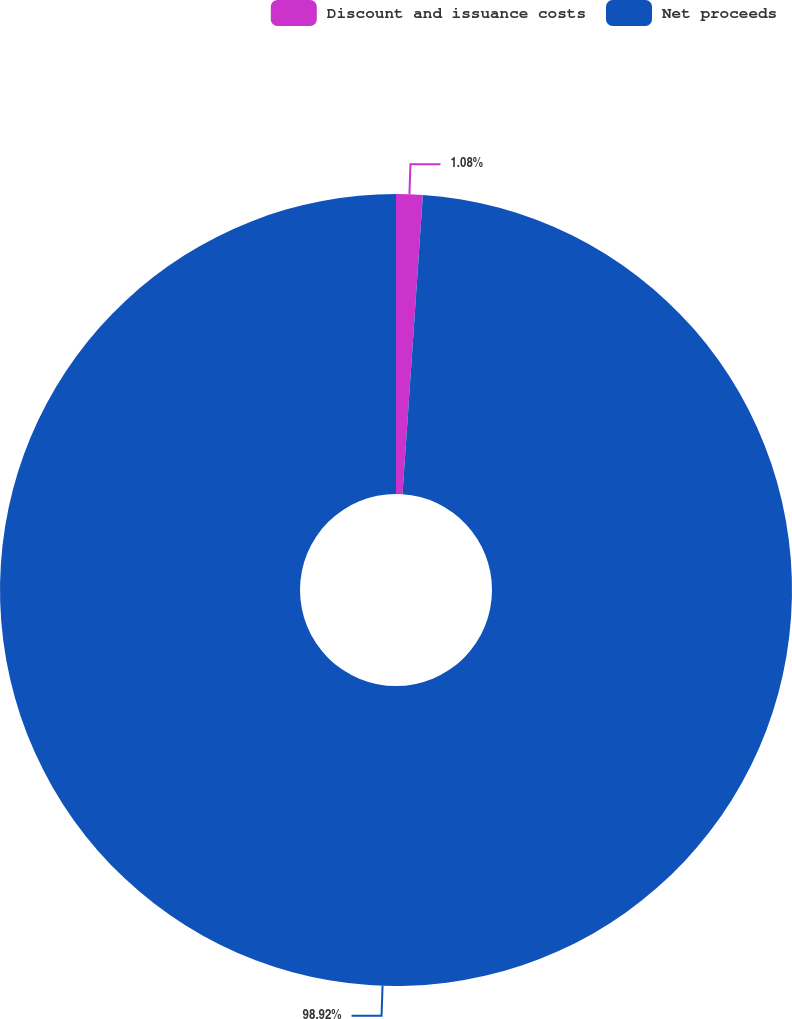Convert chart. <chart><loc_0><loc_0><loc_500><loc_500><pie_chart><fcel>Discount and issuance costs<fcel>Net proceeds<nl><fcel>1.08%<fcel>98.92%<nl></chart> 